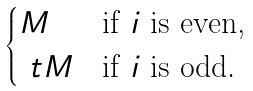Convert formula to latex. <formula><loc_0><loc_0><loc_500><loc_500>\begin{cases} M & \text {if $i$ is even,} \\ \ t M & \text {if $i$ is odd.} \end{cases}</formula> 